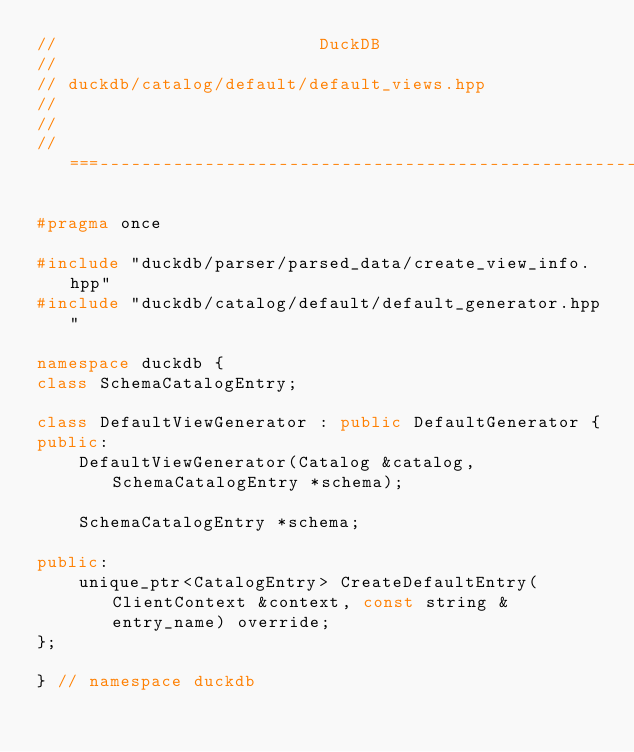<code> <loc_0><loc_0><loc_500><loc_500><_C++_>//                         DuckDB
//
// duckdb/catalog/default/default_views.hpp
//
//
//===----------------------------------------------------------------------===//

#pragma once

#include "duckdb/parser/parsed_data/create_view_info.hpp"
#include "duckdb/catalog/default/default_generator.hpp"

namespace duckdb {
class SchemaCatalogEntry;

class DefaultViewGenerator : public DefaultGenerator {
public:
	DefaultViewGenerator(Catalog &catalog, SchemaCatalogEntry *schema);

	SchemaCatalogEntry *schema;

public:
	unique_ptr<CatalogEntry> CreateDefaultEntry(ClientContext &context, const string &entry_name) override;
};

} // namespace duckdb
</code> 